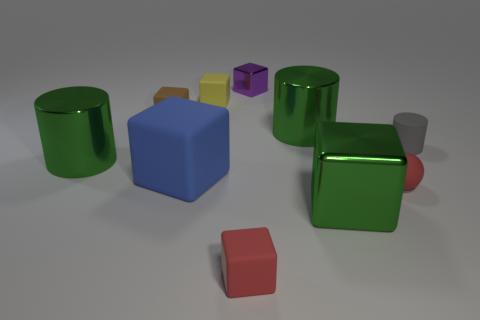Do the purple cube and the gray matte thing have the same size?
Offer a terse response. Yes. Is there anything else that has the same shape as the purple thing?
Provide a succinct answer. Yes. Is the material of the small yellow block the same as the cylinder that is left of the brown rubber block?
Offer a terse response. No. There is a small rubber cube that is left of the big blue thing; is its color the same as the tiny rubber ball?
Provide a short and direct response. No. What number of large objects are both to the left of the brown cube and right of the purple shiny object?
Offer a terse response. 0. How many other things are the same material as the tiny red block?
Ensure brevity in your answer.  5. Do the tiny cube behind the yellow cube and the small brown thing have the same material?
Provide a succinct answer. No. How big is the green metallic cylinder behind the cylinder that is left of the small thing that is to the left of the blue rubber block?
Offer a terse response. Large. How many other objects are there of the same color as the matte sphere?
Your answer should be compact. 1. There is a gray thing that is the same size as the purple metal thing; what shape is it?
Keep it short and to the point. Cylinder. 